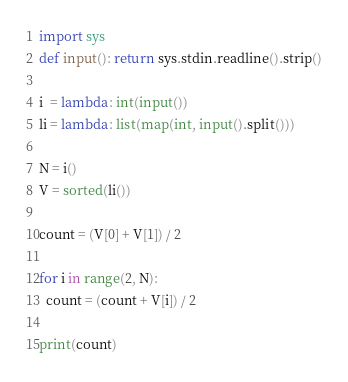Convert code to text. <code><loc_0><loc_0><loc_500><loc_500><_Python_>import sys
def input(): return sys.stdin.readline().strip()

i  = lambda: int(input())
li = lambda: list(map(int, input().split()))

N = i()
V = sorted(li())

count = (V[0] + V[1]) / 2

for i in range(2, N):
  count = (count + V[i]) / 2

print(count)</code> 